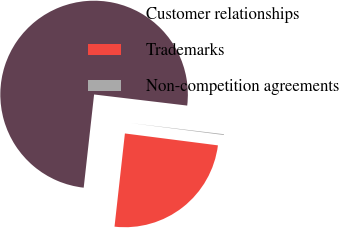<chart> <loc_0><loc_0><loc_500><loc_500><pie_chart><fcel>Customer relationships<fcel>Trademarks<fcel>Non-competition agreements<nl><fcel>75.12%<fcel>24.74%<fcel>0.14%<nl></chart> 